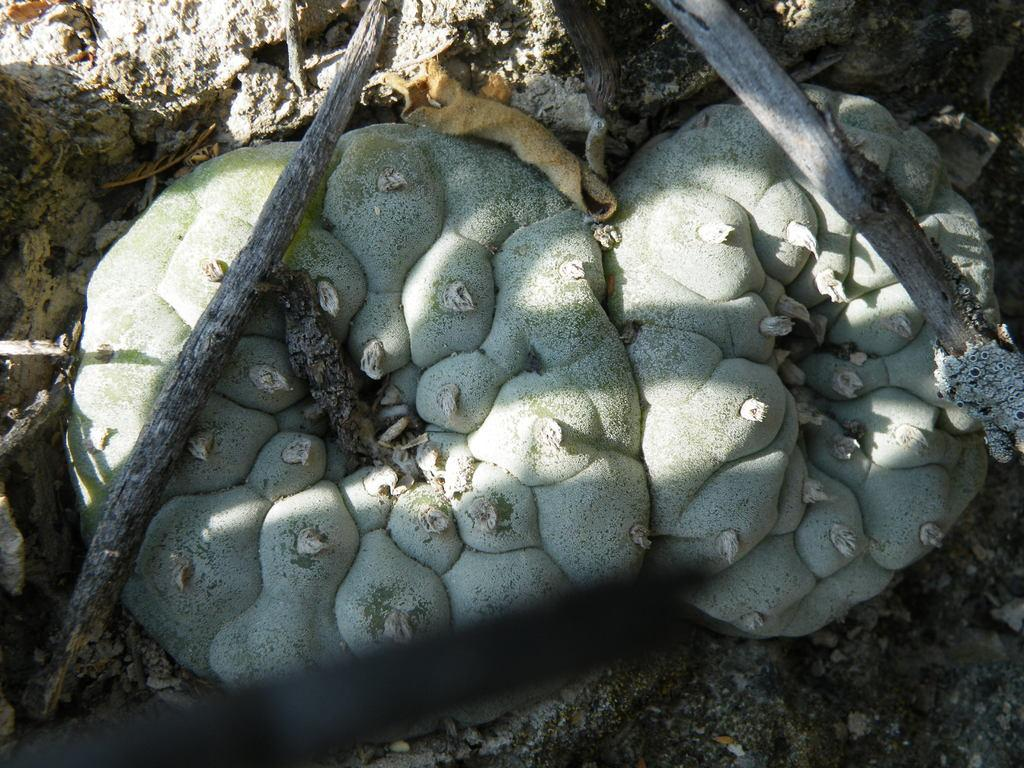What type of living organisms can be seen in the image? Plants can be seen in the image. What non-living object is present in the image? There is a rock in the image. What type of material is used for the objects in the image? There are wooden objects in the image. What type of effect does the lizard have on the plants in the image? There are no lizards present in the image, so it is not possible to determine any effect they might have on the plants. 